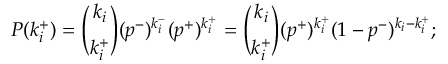<formula> <loc_0><loc_0><loc_500><loc_500>P ( k _ { i } ^ { + } ) = \binom { k _ { i } } { k _ { i } ^ { + } } ( p ^ { - } ) ^ { k _ { i } ^ { - } } ( p ^ { + } ) ^ { k _ { i } ^ { + } } = \binom { k _ { i } } { k _ { i } ^ { + } } ( p ^ { + } ) ^ { k _ { i } ^ { + } } ( 1 - p ^ { - } ) ^ { k _ { i } - k _ { i } ^ { + } } ;</formula> 